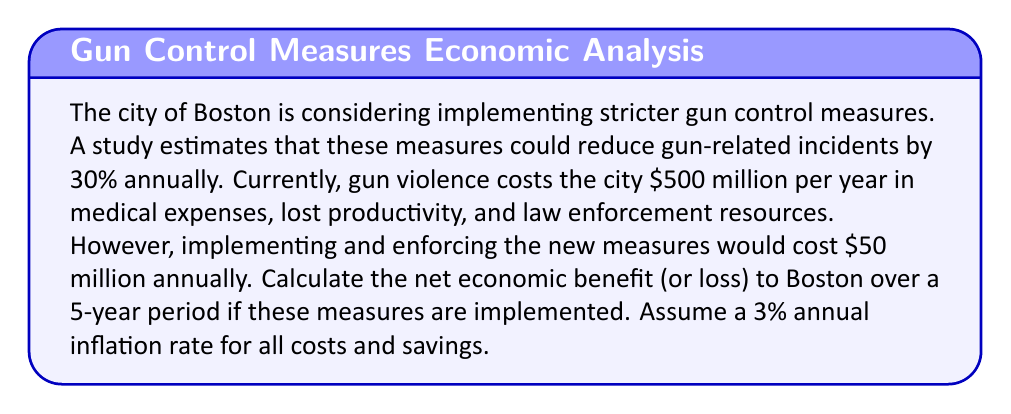Give your solution to this math problem. Let's approach this problem step-by-step:

1) First, we need to calculate the annual savings from reduced gun violence:
   $500 million * 30% = $150 million per year

2) The net annual benefit is the savings minus the implementation cost:
   $150 million - $50 million = $100 million per year

3) Now, we need to account for inflation over the 5-year period. We'll use the formula for the future value of an annuity:

   $FV = PMT * \frac{(1+r)^n - 1}{r}$

   Where:
   FV = Future Value
   PMT = Annual Payment (in this case, annual net benefit)
   r = Annual inflation rate
   n = Number of years

4) Plugging in our values:

   $FV = 100,000,000 * \frac{(1+0.03)^5 - 1}{0.03}$

5) Let's solve this step-by-step:
   $(1+0.03)^5 = 1.159274$
   $1.159274 - 1 = 0.159274$
   $0.159274 / 0.03 = 5.30913$

6) Therefore:
   $FV = 100,000,000 * 5.30913 = 530,913,000$

The net economic benefit over 5 years, accounting for inflation, is $530,913,000.
Answer: $530,913,000 